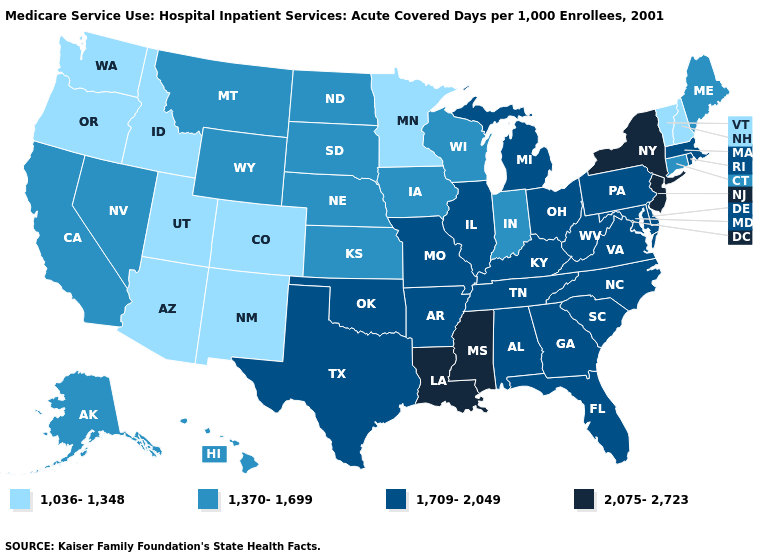What is the lowest value in the MidWest?
Quick response, please. 1,036-1,348. What is the highest value in the USA?
Be succinct. 2,075-2,723. Among the states that border Louisiana , does Mississippi have the highest value?
Keep it brief. Yes. Does the first symbol in the legend represent the smallest category?
Keep it brief. Yes. Is the legend a continuous bar?
Answer briefly. No. Is the legend a continuous bar?
Keep it brief. No. What is the value of Minnesota?
Be succinct. 1,036-1,348. Does Arkansas have a higher value than Alaska?
Give a very brief answer. Yes. Name the states that have a value in the range 2,075-2,723?
Write a very short answer. Louisiana, Mississippi, New Jersey, New York. Does the first symbol in the legend represent the smallest category?
Write a very short answer. Yes. Name the states that have a value in the range 2,075-2,723?
Quick response, please. Louisiana, Mississippi, New Jersey, New York. What is the value of Missouri?
Write a very short answer. 1,709-2,049. Name the states that have a value in the range 2,075-2,723?
Write a very short answer. Louisiana, Mississippi, New Jersey, New York. Does Louisiana have the lowest value in the South?
Write a very short answer. No. What is the value of Utah?
Concise answer only. 1,036-1,348. 